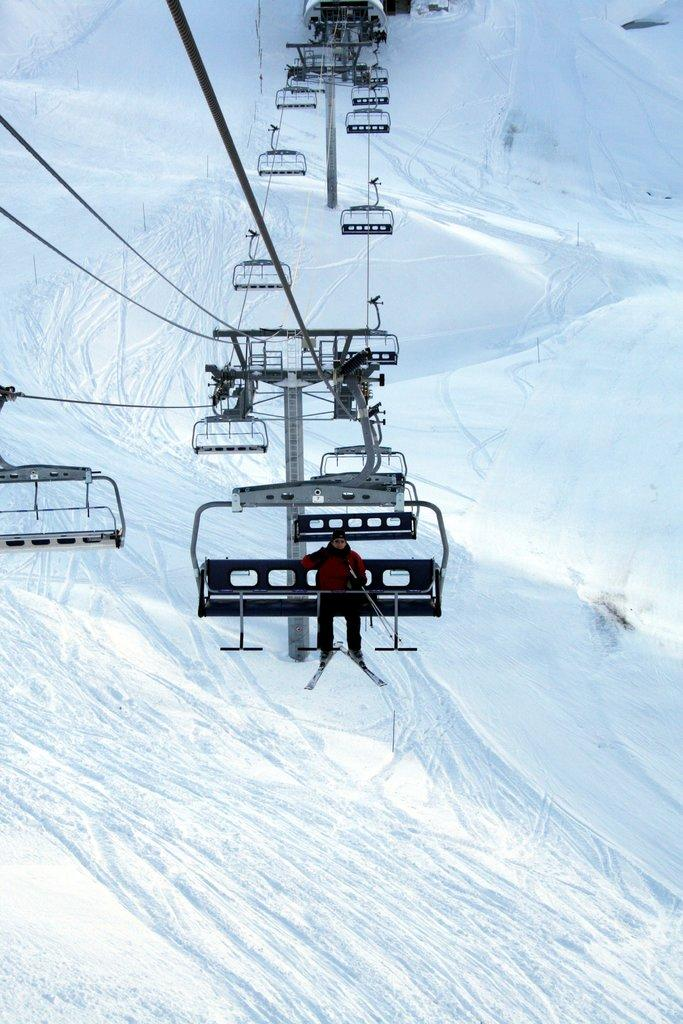What is the predominant weather condition in the image? There is snow in the image, indicating a cold and wintry environment. What can be seen in the image that is related to winter sports? There is a ski-lift ropeway in the image, which is commonly used for skiing and snowboarding. Can you describe the person in the image? A person is sitting on the ski-lift ropeway chair, suggesting they are likely participating in winter sports. What is the distance between the person and the fact in the image? There is no "fact" present in the image; it only features snow, a ski-lift ropeway, and a person sitting on the chair. 